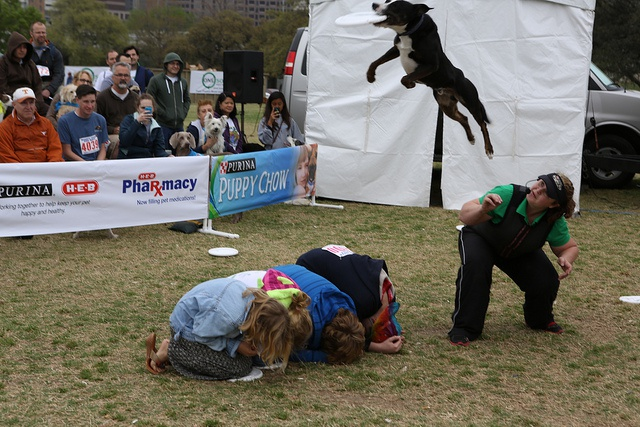Describe the objects in this image and their specific colors. I can see people in darkgreen, black, maroon, and gray tones, people in darkgreen, black, maroon, gray, and darkgray tones, people in darkgreen, black, gray, and maroon tones, truck in darkgreen, black, gray, darkgray, and lightgray tones, and dog in darkgreen, black, gray, darkgray, and lightgray tones in this image. 